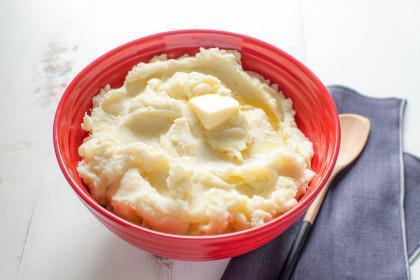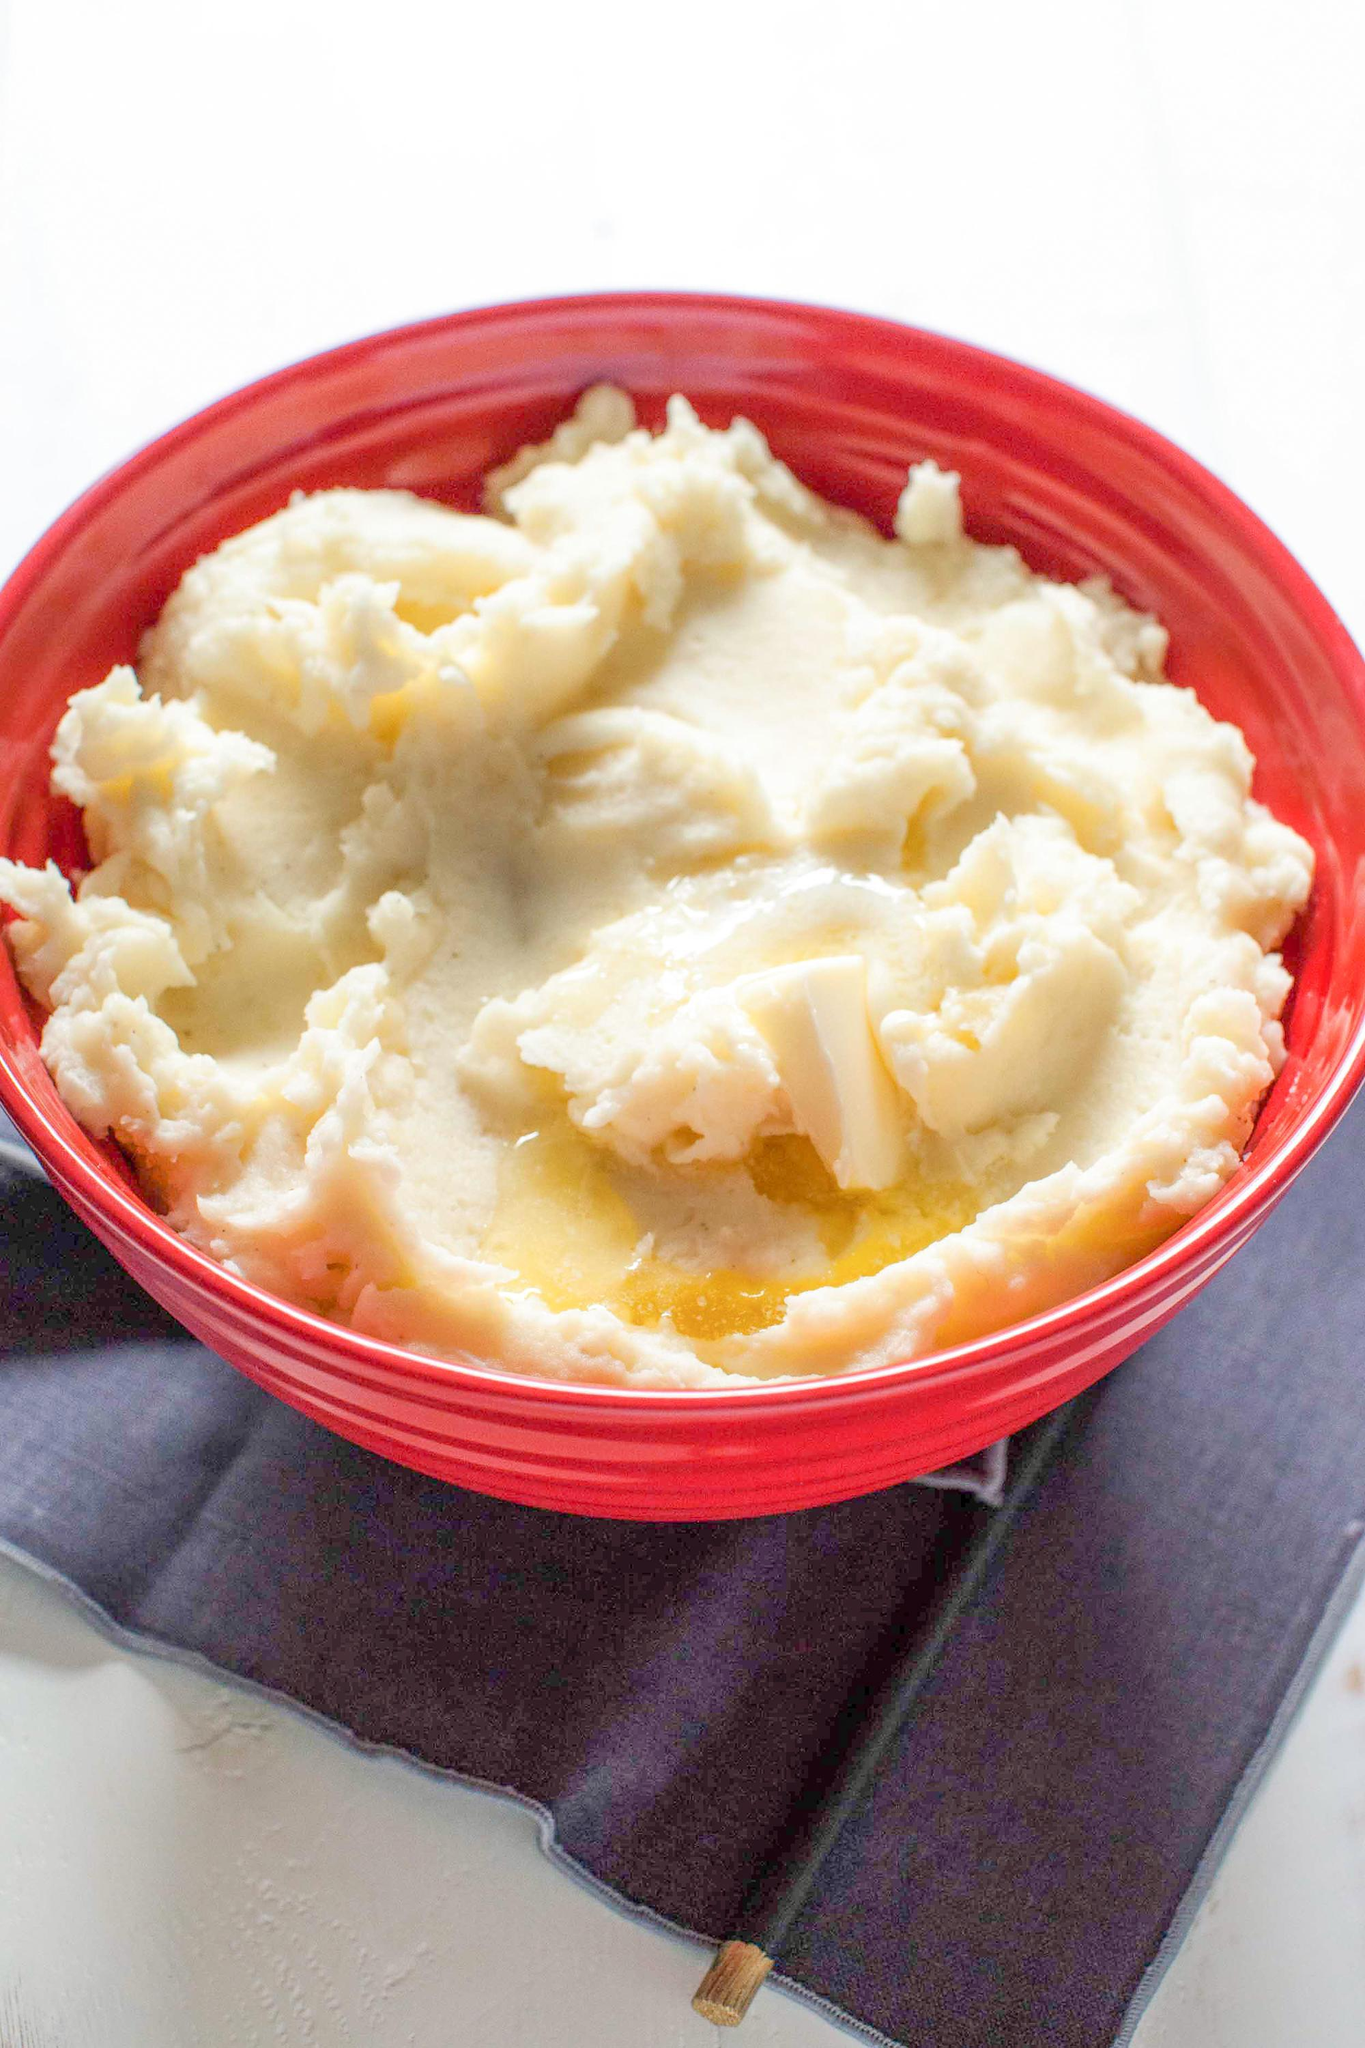The first image is the image on the left, the second image is the image on the right. For the images shown, is this caption "A spoon is next to a bowl in at least one image." true? Answer yes or no. Yes. The first image is the image on the left, the second image is the image on the right. Evaluate the accuracy of this statement regarding the images: "There is a green bowl in one of the images". Is it true? Answer yes or no. No. 